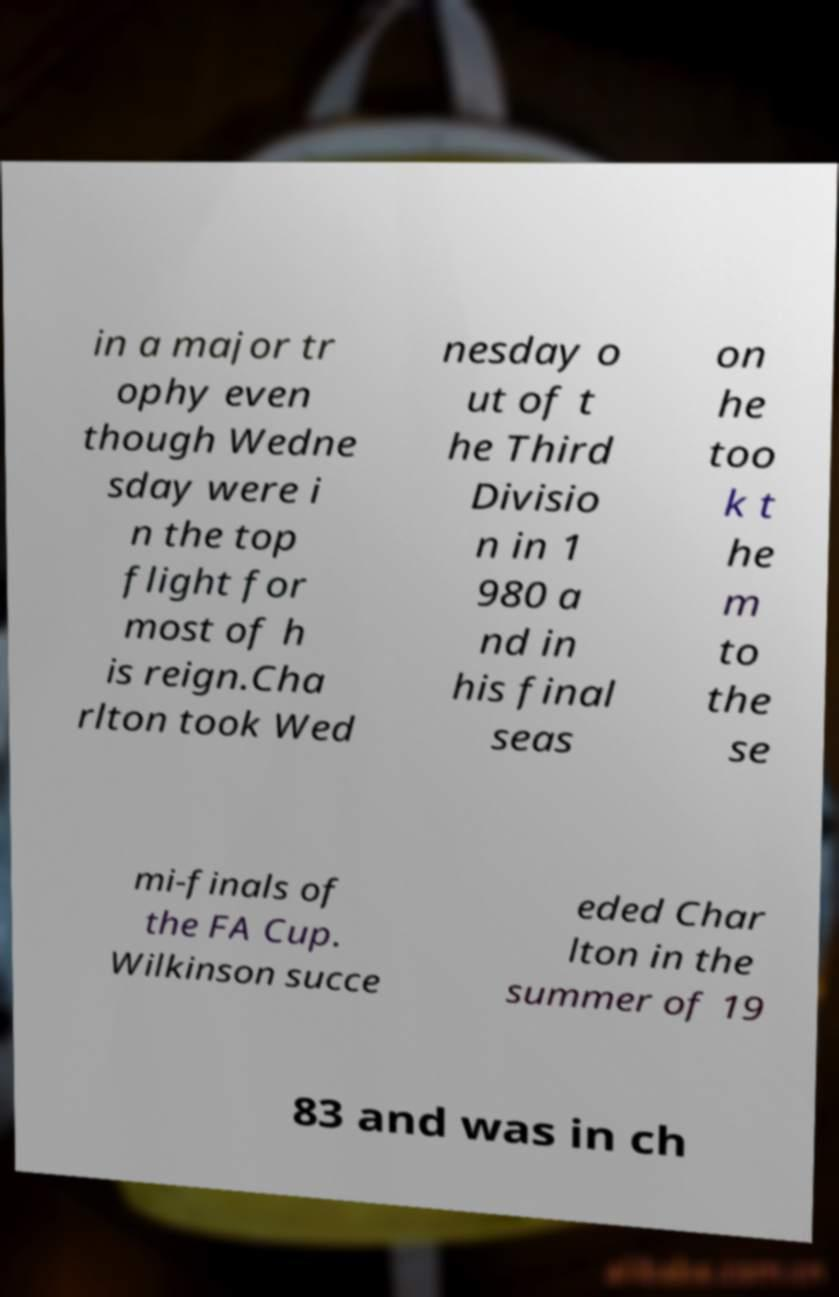Could you assist in decoding the text presented in this image and type it out clearly? in a major tr ophy even though Wedne sday were i n the top flight for most of h is reign.Cha rlton took Wed nesday o ut of t he Third Divisio n in 1 980 a nd in his final seas on he too k t he m to the se mi-finals of the FA Cup. Wilkinson succe eded Char lton in the summer of 19 83 and was in ch 